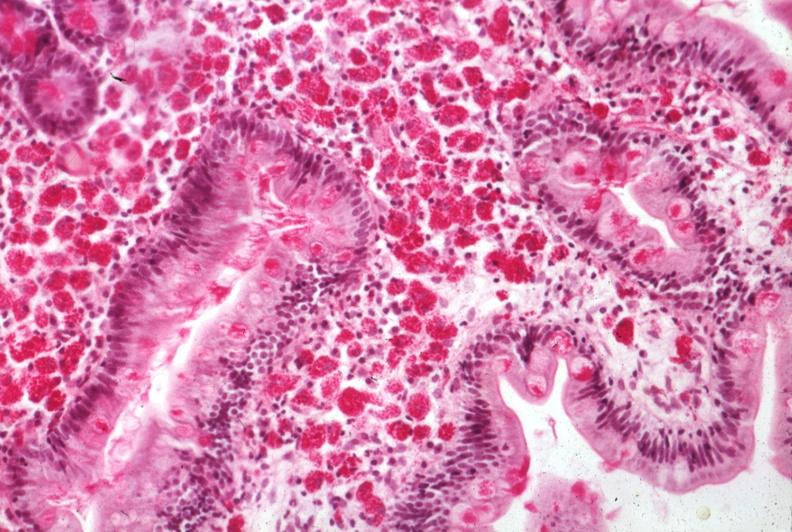does this image show med pas hematoxylin section of mucosa excellent example source?
Answer the question using a single word or phrase. Yes 